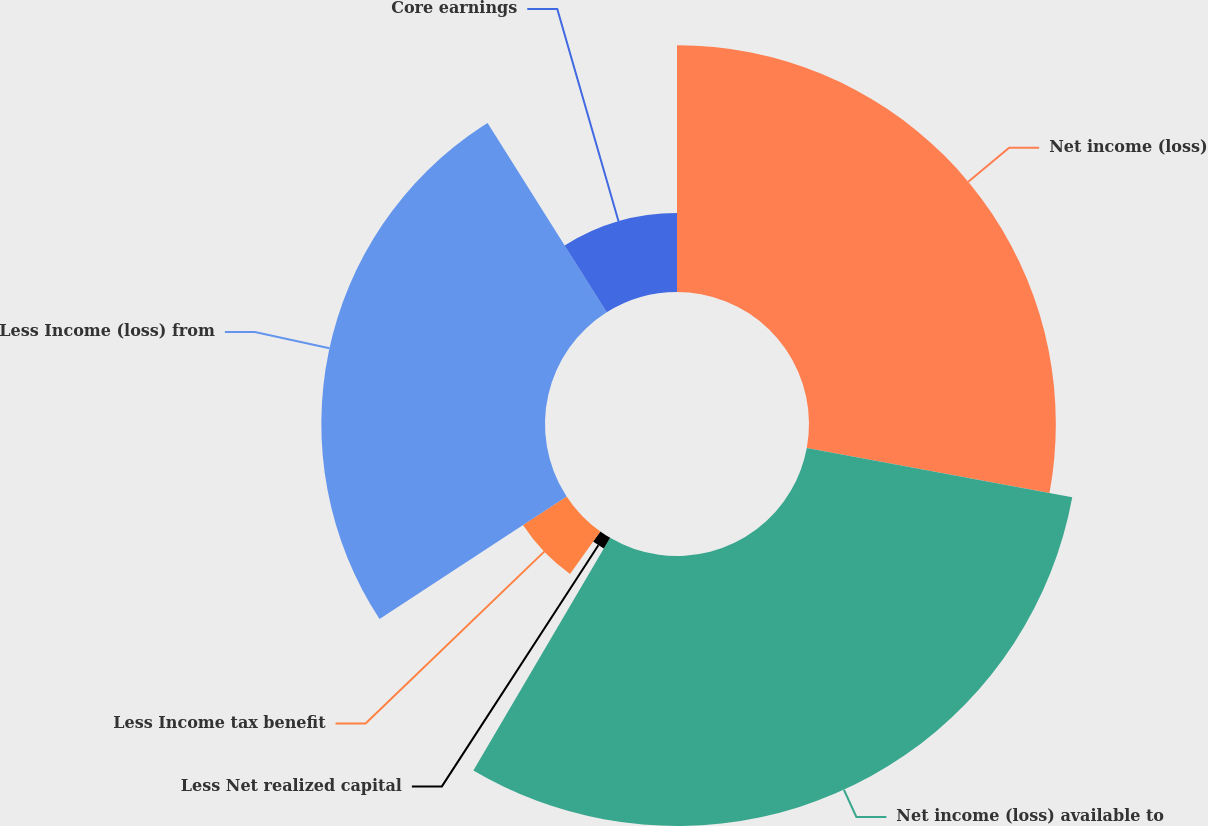<chart> <loc_0><loc_0><loc_500><loc_500><pie_chart><fcel>Net income (loss)<fcel>Net income (loss) available to<fcel>Less Net realized capital<fcel>Less Income tax benefit<fcel>Less Income (loss) from<fcel>Core earnings<nl><fcel>27.92%<fcel>30.54%<fcel>1.41%<fcel>5.9%<fcel>25.3%<fcel>8.94%<nl></chart> 